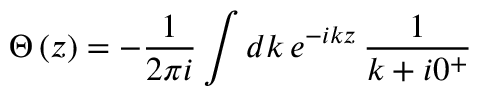<formula> <loc_0><loc_0><loc_500><loc_500>\Theta \left ( z \right ) = - \frac { 1 } { 2 \pi i } \int d k \, e ^ { - i k z } \, \frac { 1 } { k + i 0 ^ { + } }</formula> 